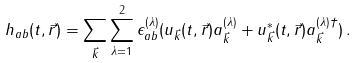<formula> <loc_0><loc_0><loc_500><loc_500>h _ { a b } ( t , \vec { r } ) = \sum _ { \vec { k } } \sum _ { \lambda = 1 } ^ { 2 } \epsilon _ { a b } ^ { ( \lambda ) } ( u _ { \vec { k } } ( t , \vec { r } ) a _ { \vec { k } } ^ { ( \lambda ) } + u _ { \vec { k } } ^ { * } ( t , \vec { r } ) a _ { \vec { k } } ^ { ( \lambda ) \dagger } ) \, .</formula> 